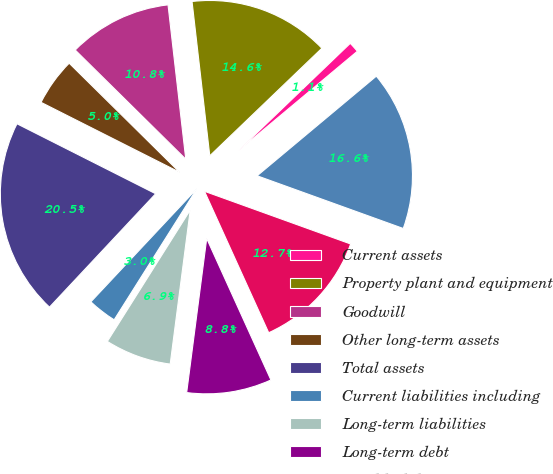Convert chart to OTSL. <chart><loc_0><loc_0><loc_500><loc_500><pie_chart><fcel>Current assets<fcel>Property plant and equipment<fcel>Goodwill<fcel>Other long-term assets<fcel>Total assets<fcel>Current liabilities including<fcel>Long-term liabilities<fcel>Long-term debt<fcel>Total liabilities<fcel>Total purchase price<nl><fcel>1.09%<fcel>14.65%<fcel>10.78%<fcel>4.96%<fcel>20.46%<fcel>3.02%<fcel>6.9%<fcel>8.84%<fcel>12.71%<fcel>16.59%<nl></chart> 